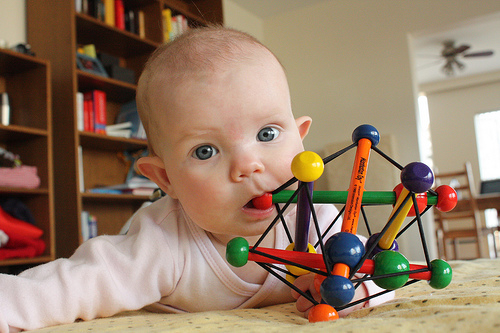<image>
Is the bookshelf next to the baby? Yes. The bookshelf is positioned adjacent to the baby, located nearby in the same general area. Is there a kid under the toy? No. The kid is not positioned under the toy. The vertical relationship between these objects is different. Is there a baby behind the book? No. The baby is not behind the book. From this viewpoint, the baby appears to be positioned elsewhere in the scene. 